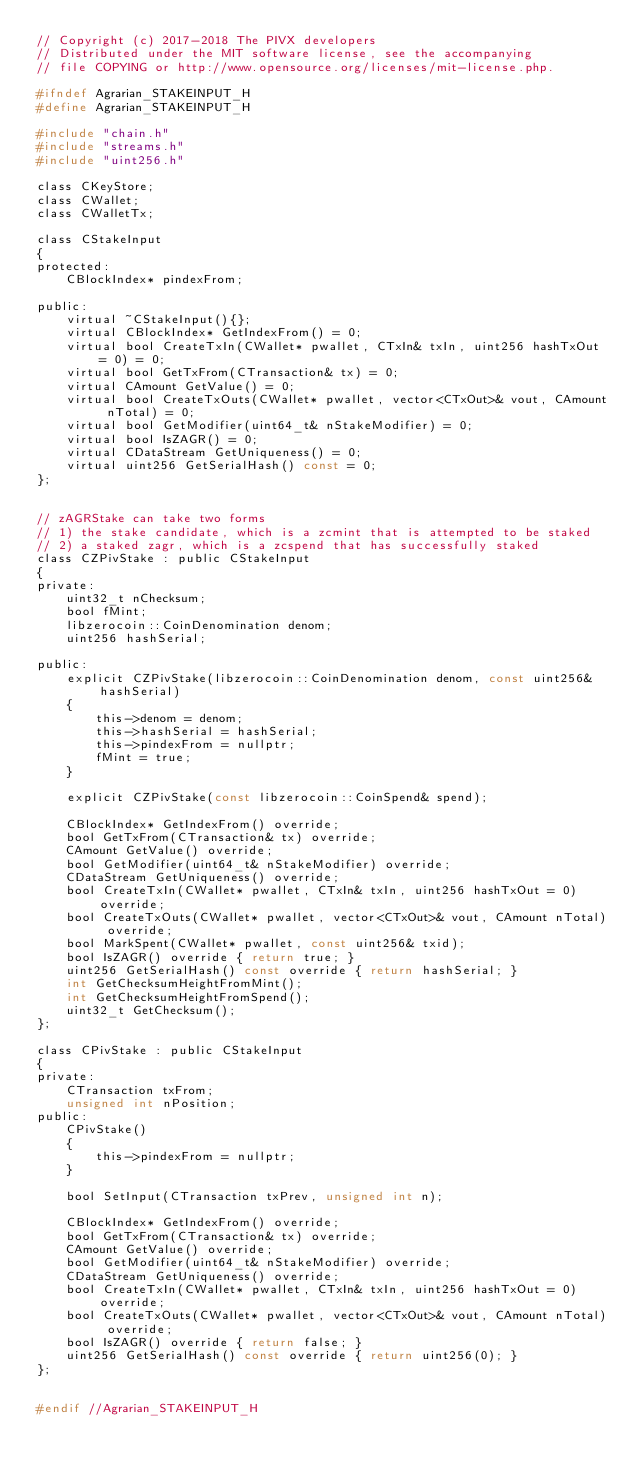Convert code to text. <code><loc_0><loc_0><loc_500><loc_500><_C_>// Copyright (c) 2017-2018 The PIVX developers
// Distributed under the MIT software license, see the accompanying
// file COPYING or http://www.opensource.org/licenses/mit-license.php.

#ifndef Agrarian_STAKEINPUT_H
#define Agrarian_STAKEINPUT_H

#include "chain.h"
#include "streams.h"
#include "uint256.h"

class CKeyStore;
class CWallet;
class CWalletTx;

class CStakeInput
{
protected:
    CBlockIndex* pindexFrom;

public:
    virtual ~CStakeInput(){};
    virtual CBlockIndex* GetIndexFrom() = 0;
    virtual bool CreateTxIn(CWallet* pwallet, CTxIn& txIn, uint256 hashTxOut = 0) = 0;
    virtual bool GetTxFrom(CTransaction& tx) = 0;
    virtual CAmount GetValue() = 0;
    virtual bool CreateTxOuts(CWallet* pwallet, vector<CTxOut>& vout, CAmount nTotal) = 0;
    virtual bool GetModifier(uint64_t& nStakeModifier) = 0;
    virtual bool IsZAGR() = 0;
    virtual CDataStream GetUniqueness() = 0;
    virtual uint256 GetSerialHash() const = 0;
};


// zAGRStake can take two forms
// 1) the stake candidate, which is a zcmint that is attempted to be staked
// 2) a staked zagr, which is a zcspend that has successfully staked
class CZPivStake : public CStakeInput
{
private:
    uint32_t nChecksum;
    bool fMint;
    libzerocoin::CoinDenomination denom;
    uint256 hashSerial;

public:
    explicit CZPivStake(libzerocoin::CoinDenomination denom, const uint256& hashSerial)
    {
        this->denom = denom;
        this->hashSerial = hashSerial;
        this->pindexFrom = nullptr;
        fMint = true;
    }

    explicit CZPivStake(const libzerocoin::CoinSpend& spend);

    CBlockIndex* GetIndexFrom() override;
    bool GetTxFrom(CTransaction& tx) override;
    CAmount GetValue() override;
    bool GetModifier(uint64_t& nStakeModifier) override;
    CDataStream GetUniqueness() override;
    bool CreateTxIn(CWallet* pwallet, CTxIn& txIn, uint256 hashTxOut = 0) override;
    bool CreateTxOuts(CWallet* pwallet, vector<CTxOut>& vout, CAmount nTotal) override;
    bool MarkSpent(CWallet* pwallet, const uint256& txid);
    bool IsZAGR() override { return true; }
    uint256 GetSerialHash() const override { return hashSerial; }
    int GetChecksumHeightFromMint();
    int GetChecksumHeightFromSpend();
    uint32_t GetChecksum();
};

class CPivStake : public CStakeInput
{
private:
    CTransaction txFrom;
    unsigned int nPosition;
public:
    CPivStake()
    {
        this->pindexFrom = nullptr;
    }

    bool SetInput(CTransaction txPrev, unsigned int n);

    CBlockIndex* GetIndexFrom() override;
    bool GetTxFrom(CTransaction& tx) override;
    CAmount GetValue() override;
    bool GetModifier(uint64_t& nStakeModifier) override;
    CDataStream GetUniqueness() override;
    bool CreateTxIn(CWallet* pwallet, CTxIn& txIn, uint256 hashTxOut = 0) override;
    bool CreateTxOuts(CWallet* pwallet, vector<CTxOut>& vout, CAmount nTotal) override;
    bool IsZAGR() override { return false; }
    uint256 GetSerialHash() const override { return uint256(0); }
};


#endif //Agrarian_STAKEINPUT_H
</code> 